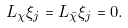Convert formula to latex. <formula><loc_0><loc_0><loc_500><loc_500>L _ { \chi } \xi _ { j } = L _ { \bar { \chi } } \xi _ { j } = 0 .</formula> 